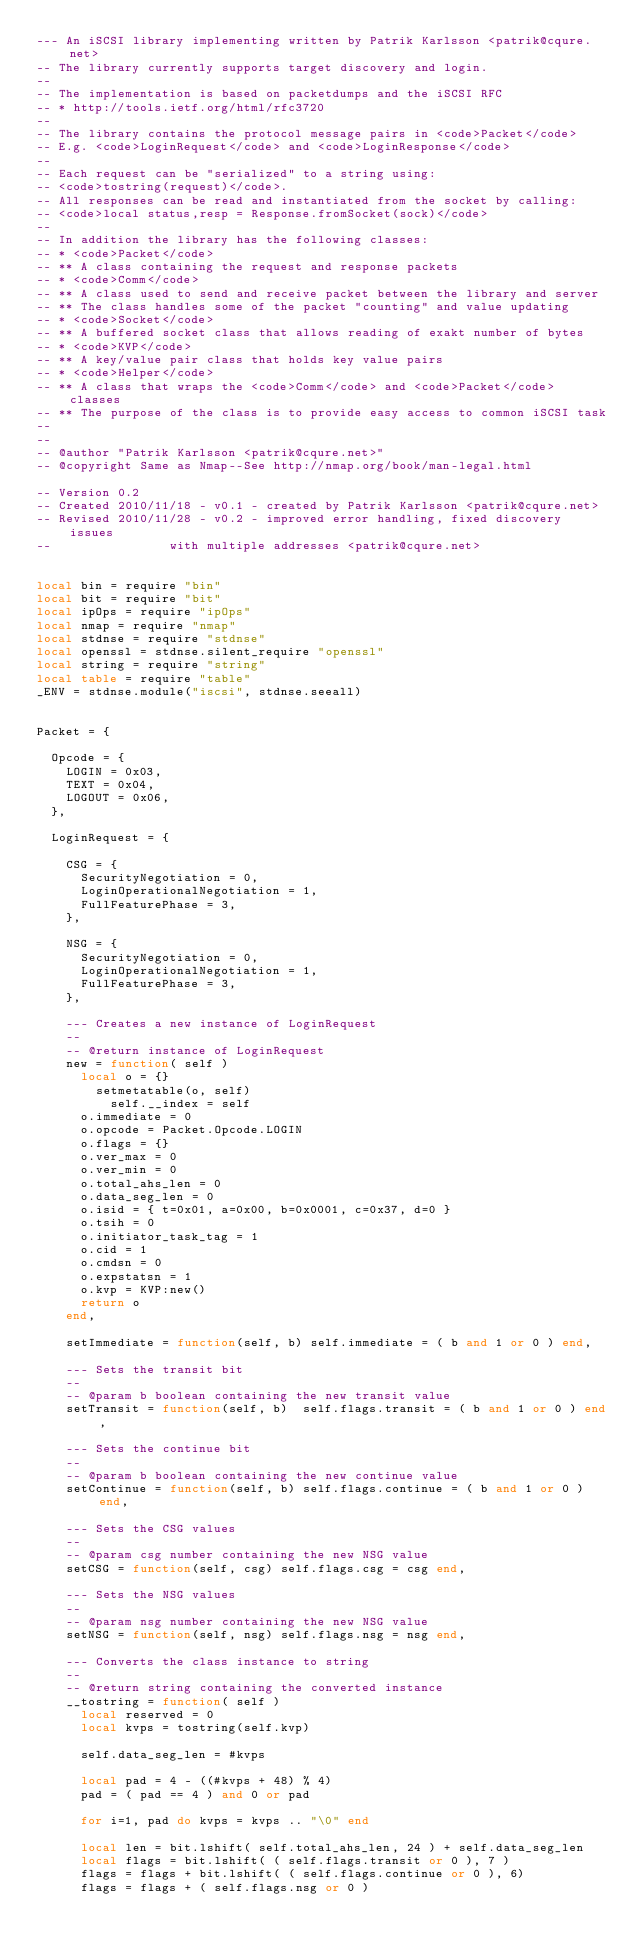Convert code to text. <code><loc_0><loc_0><loc_500><loc_500><_Lua_>--- An iSCSI library implementing written by Patrik Karlsson <patrik@cqure.net>
-- The library currently supports target discovery and login.
--
-- The implementation is based on packetdumps and the iSCSI RFC
-- * http://tools.ietf.org/html/rfc3720
--
-- The library contains the protocol message pairs in <code>Packet</code>
-- E.g. <code>LoginRequest</code> and <code>LoginResponse</code>
--
-- Each request can be "serialized" to a string using:
-- <code>tostring(request)</code>. 
-- All responses can be read and instantiated from the socket by calling:
-- <code>local status,resp = Response.fromSocket(sock)</code>
--
-- In addition the library has the following classes:
-- * <code>Packet</code>
-- ** A class containing the request and response packets
-- * <code>Comm</code>
-- ** A class used to send and receive packet between the library and server
-- ** The class handles some of the packet "counting" and value updating
-- * <code>Socket</code>
-- ** A buffered socket class that allows reading of exakt number of bytes
-- * <code>KVP</code>
-- ** A key/value pair class that holds key value pairs
-- * <code>Helper</code>
-- ** A class that wraps the <code>Comm</code> and <code>Packet</code> classes
-- ** The purpose of the class is to provide easy access to common iSCSI task
--
--
-- @author "Patrik Karlsson <patrik@cqure.net>"
-- @copyright Same as Nmap--See http://nmap.org/book/man-legal.html

-- Version 0.2
-- Created 2010/11/18 - v0.1 - created by Patrik Karlsson <patrik@cqure.net>
-- Revised 2010/11/28 - v0.2 - improved error handling, fixed discovery issues
--								with multiple addresses <patrik@cqure.net>


local bin = require "bin"
local bit = require "bit"
local ipOps = require "ipOps"
local nmap = require "nmap"
local stdnse = require "stdnse"
local openssl = stdnse.silent_require "openssl"
local string = require "string"
local table = require "table"
_ENV = stdnse.module("iscsi", stdnse.seeall)


Packet = {
	
	Opcode = { 
		LOGIN = 0x03,
		TEXT = 0x04,
		LOGOUT = 0x06,
	},
	
	LoginRequest = {
		
		CSG = {
			SecurityNegotiation = 0,
			LoginOperationalNegotiation = 1,
			FullFeaturePhase = 3,
		},

		NSG = {
			SecurityNegotiation = 0,
			LoginOperationalNegotiation = 1,
			FullFeaturePhase = 3,
		},
		
		--- Creates a new instance of LoginRequest
		--
		-- @return instance of LoginRequest
		new = function( self )
			local o = {}
		   	setmetatable(o, self)
	        self.__index = self
			o.immediate = 0
			o.opcode = Packet.Opcode.LOGIN
			o.flags = {}
			o.ver_max = 0
			o.ver_min = 0
			o.total_ahs_len = 0
			o.data_seg_len = 0
			o.isid = { t=0x01, a=0x00, b=0x0001, c=0x37, d=0 }
			o.tsih = 0
			o.initiator_task_tag = 1
			o.cid = 1
			o.cmdsn = 0
			o.expstatsn = 1
			o.kvp = KVP:new()
			return o
		end,
		
		setImmediate = function(self, b) self.immediate = ( b and 1 or 0 ) end,
		
		--- Sets the transit bit
		--
		-- @param b boolean containing the new transit value
		setTransit = function(self, b)	self.flags.transit = ( b and 1 or 0 ) end,

		--- Sets the continue bit
		--
		-- @param b boolean containing the new continue value
		setContinue = function(self, b) self.flags.continue = ( b and 1 or 0 ) end,

		--- Sets the CSG values
		--
		-- @param csg number containing the new NSG value 
		setCSG = function(self, csg) self.flags.csg = csg end,

		--- Sets the NSG values
		--
		-- @param nsg number containing the new NSG value 
		setNSG = function(self, nsg) self.flags.nsg = nsg end,

		--- Converts the class instance to string
		--
		-- @return string containing the converted instance
		__tostring = function( self )
			local reserved = 0
			local kvps = tostring(self.kvp)

			self.data_seg_len = #kvps

			local pad = 4 - ((#kvps + 48) % 4)
			pad = ( pad == 4 ) and 0 or pad

			for i=1, pad do kvps = kvps .. "\0" end

			local len = bit.lshift( self.total_ahs_len, 24 ) + self.data_seg_len
			local flags = bit.lshift( ( self.flags.transit or 0 ), 7 ) 
			flags = flags + bit.lshift( ( self.flags.continue or 0 ), 6)
			flags = flags + ( self.flags.nsg or 0 )</code> 